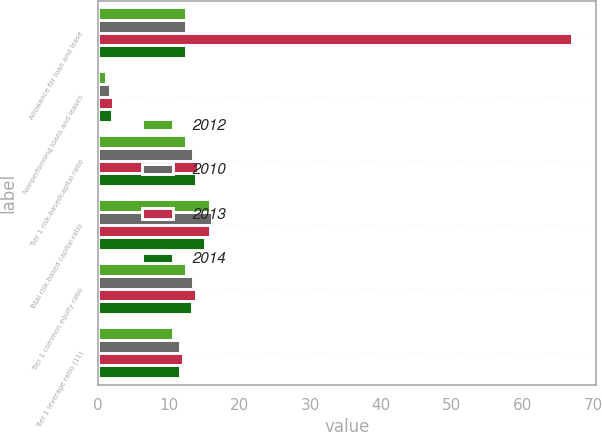Convert chart to OTSL. <chart><loc_0><loc_0><loc_500><loc_500><stacked_bar_chart><ecel><fcel>Allowance for loan and lease<fcel>Nonperforming loans and leases<fcel>Tier 1 risk-basedcapital ratio<fcel>Total risk-based capital ratio<fcel>Tier 1 common equity ratio<fcel>Tier 1 leverage ratio (11)<nl><fcel>2012<fcel>12.4<fcel>1.18<fcel>12.4<fcel>15.8<fcel>12.4<fcel>10.6<nl><fcel>2010<fcel>12.4<fcel>1.65<fcel>13.5<fcel>16.1<fcel>13.5<fcel>11.6<nl><fcel>2013<fcel>67<fcel>2.14<fcel>14.2<fcel>15.8<fcel>13.9<fcel>12.1<nl><fcel>2014<fcel>12.4<fcel>2.06<fcel>13.9<fcel>15.1<fcel>13.3<fcel>11.6<nl></chart> 